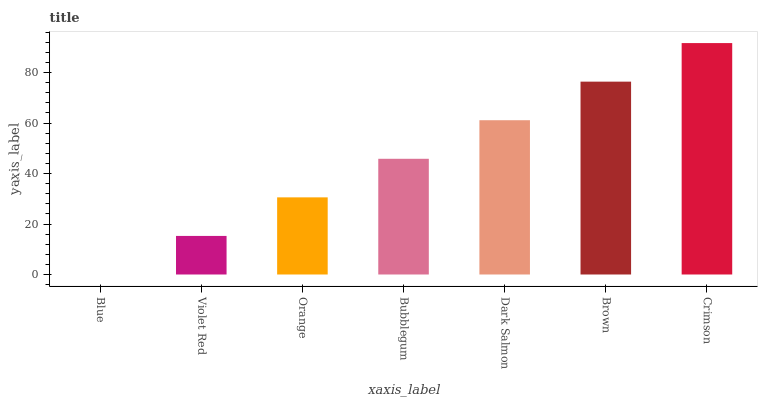Is Blue the minimum?
Answer yes or no. Yes. Is Crimson the maximum?
Answer yes or no. Yes. Is Violet Red the minimum?
Answer yes or no. No. Is Violet Red the maximum?
Answer yes or no. No. Is Violet Red greater than Blue?
Answer yes or no. Yes. Is Blue less than Violet Red?
Answer yes or no. Yes. Is Blue greater than Violet Red?
Answer yes or no. No. Is Violet Red less than Blue?
Answer yes or no. No. Is Bubblegum the high median?
Answer yes or no. Yes. Is Bubblegum the low median?
Answer yes or no. Yes. Is Blue the high median?
Answer yes or no. No. Is Crimson the low median?
Answer yes or no. No. 